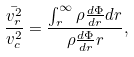<formula> <loc_0><loc_0><loc_500><loc_500>\frac { \bar { v _ { r } ^ { 2 } } } { v _ { c } ^ { 2 } } = \frac { \int _ { r } ^ { \infty } \rho \frac { d \Phi } { d r } d r } { \rho \frac { d \Phi } { d r } r } ,</formula> 